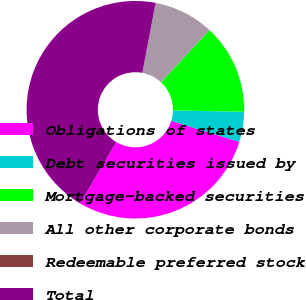<chart> <loc_0><loc_0><loc_500><loc_500><pie_chart><fcel>Obligations of states<fcel>Debt securities issued by<fcel>Mortgage-backed securities<fcel>All other corporate bonds<fcel>Redeemable preferred stock<fcel>Total<nl><fcel>28.71%<fcel>4.48%<fcel>13.37%<fcel>8.92%<fcel>0.03%<fcel>44.49%<nl></chart> 